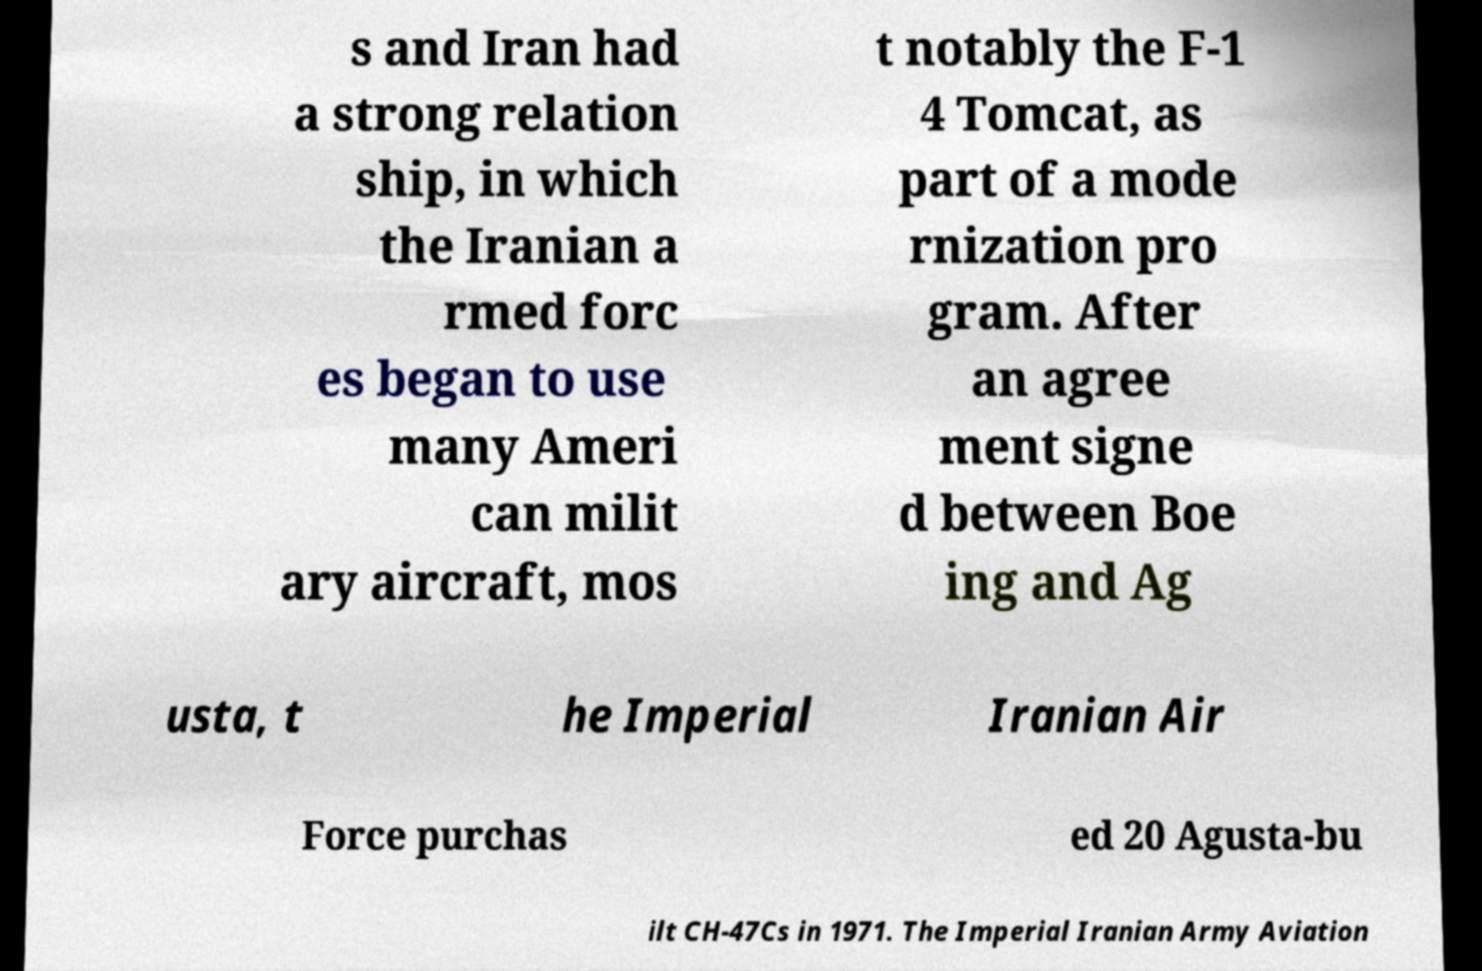Please identify and transcribe the text found in this image. s and Iran had a strong relation ship, in which the Iranian a rmed forc es began to use many Ameri can milit ary aircraft, mos t notably the F-1 4 Tomcat, as part of a mode rnization pro gram. After an agree ment signe d between Boe ing and Ag usta, t he Imperial Iranian Air Force purchas ed 20 Agusta-bu ilt CH-47Cs in 1971. The Imperial Iranian Army Aviation 